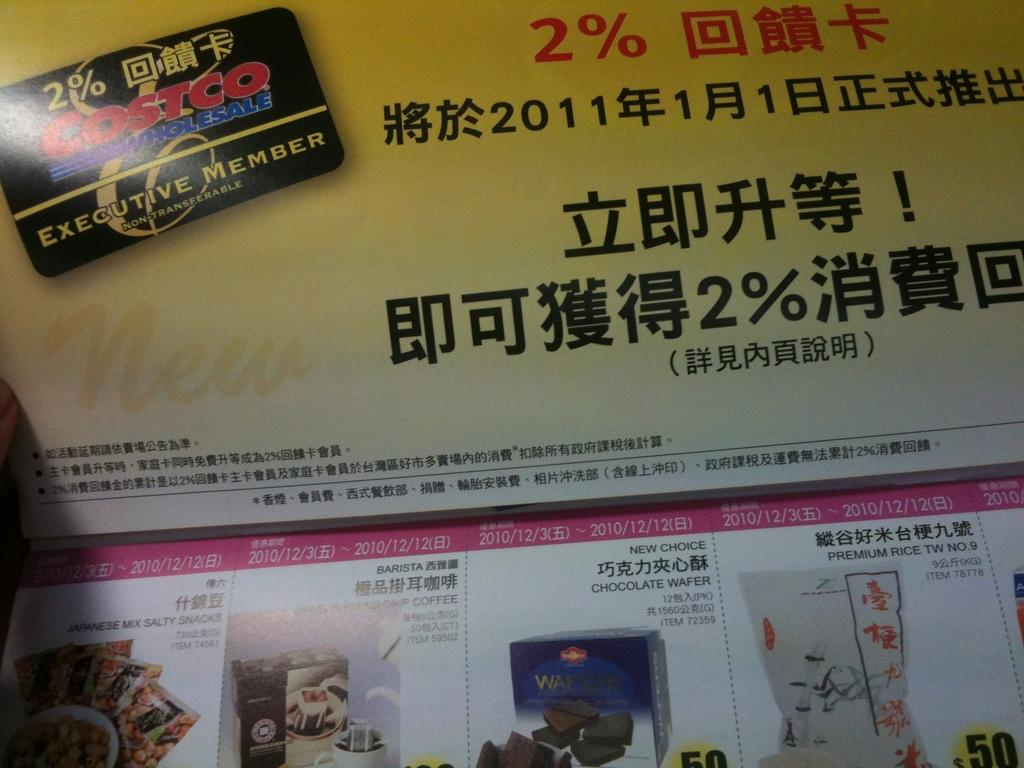What is present in the image that contains information or visuals? There is a poster in the image. What can be found on the poster besides pictures? There is text on the poster. What type of content is displayed on the poster? The poster contains both text and pictures. How many trucks are visible in the image? There are no trucks present in the image; it only features a poster with text and pictures. What type of oil is being used in the image? There is no oil present in the image. 